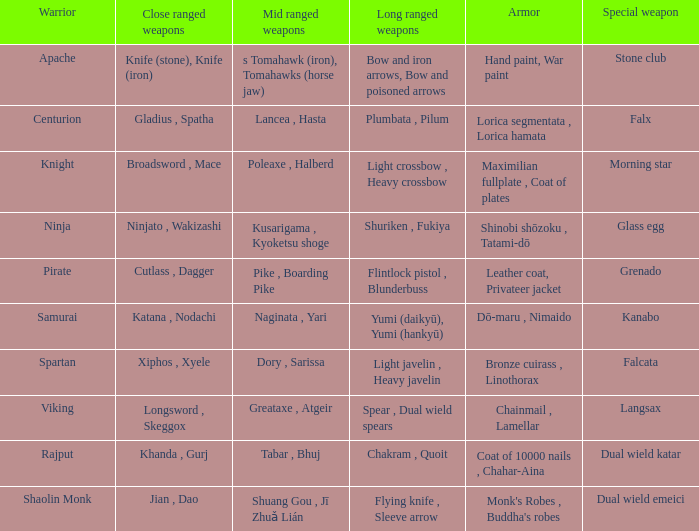If the exceptional weapon is the grenado, what is the defensive equipment? Leather coat, Privateer jacket. 